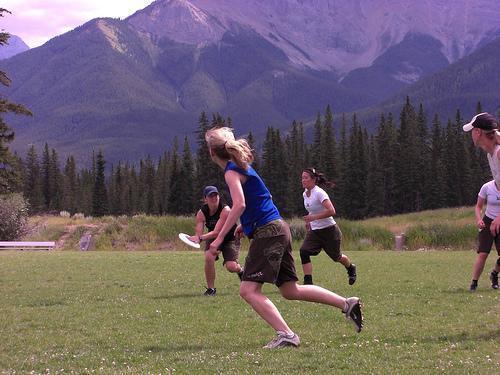How many people are in the photo?
Give a very brief answer. 5. 